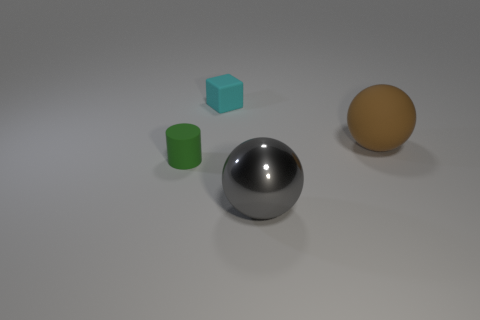Add 4 gray metal balls. How many objects exist? 8 Subtract all brown spheres. How many spheres are left? 1 Subtract all cubes. How many objects are left? 3 Subtract 1 cubes. How many cubes are left? 0 Subtract all brown blocks. How many brown spheres are left? 1 Add 2 big red metal cylinders. How many big red metal cylinders exist? 2 Subtract 1 cyan cubes. How many objects are left? 3 Subtract all brown spheres. Subtract all blue cylinders. How many spheres are left? 1 Subtract all brown matte balls. Subtract all big shiny cubes. How many objects are left? 3 Add 4 large shiny objects. How many large shiny objects are left? 5 